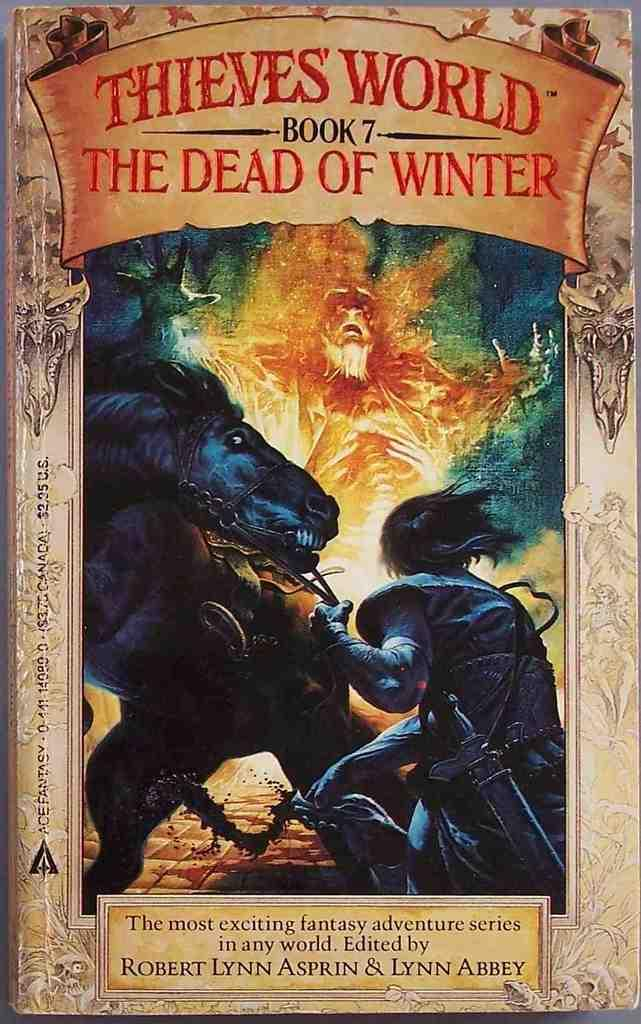<image>
Offer a succinct explanation of the picture presented. Book 7 was edited by Robert Lynn Asprin and Lynn Abbey. 